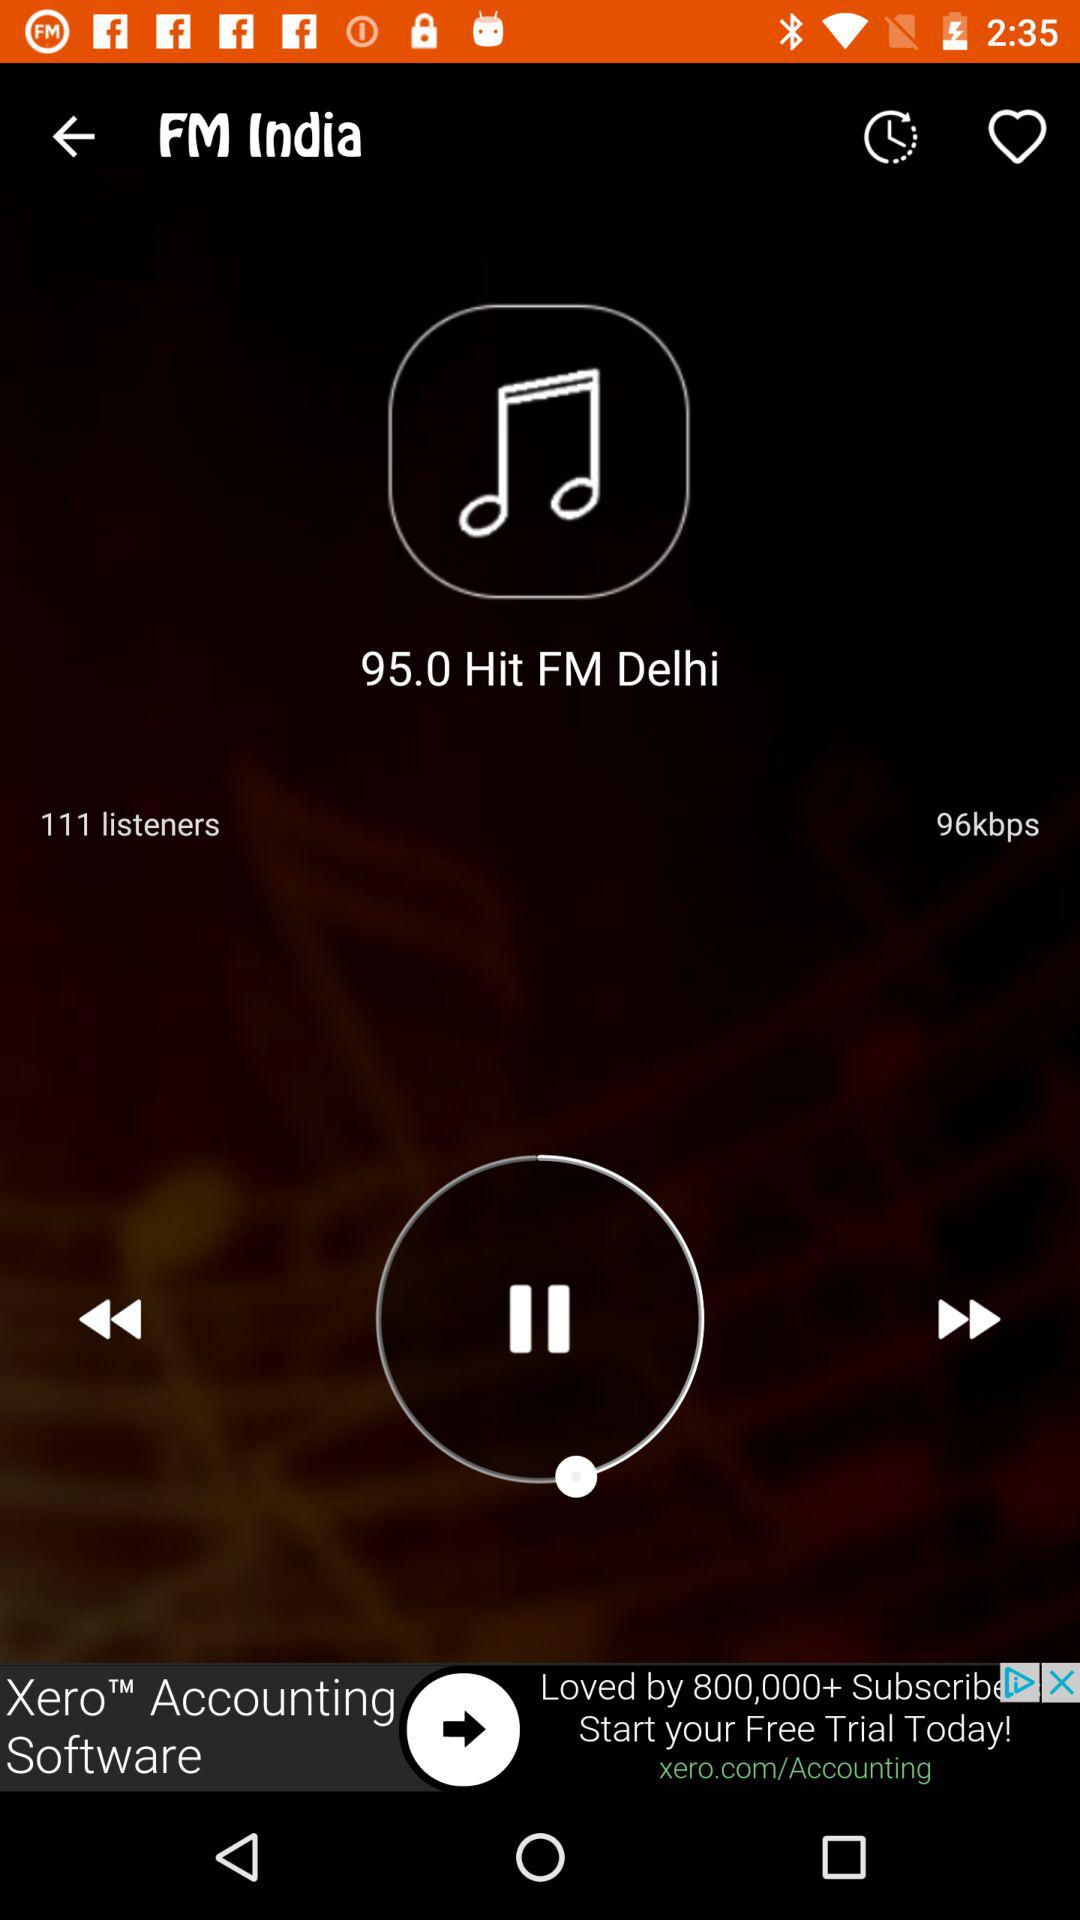What is the radio station? The radio station is "95.0 Hit FM Delhi". 